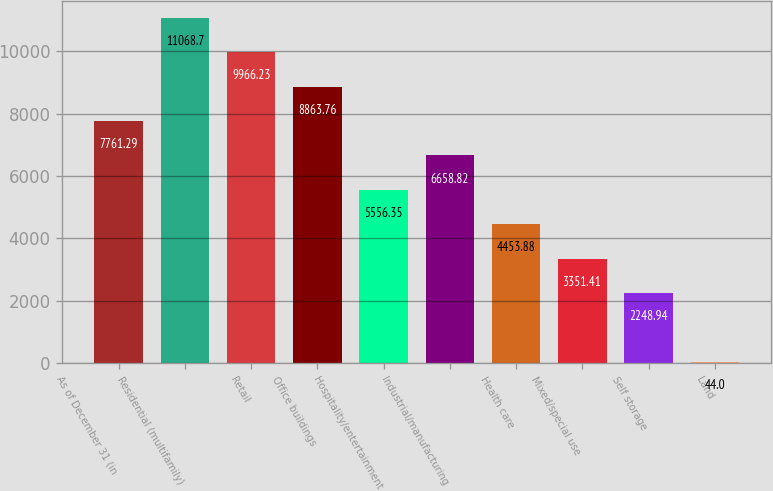Convert chart. <chart><loc_0><loc_0><loc_500><loc_500><bar_chart><fcel>As of December 31 (in<fcel>Residential (multifamily)<fcel>Retail<fcel>Office buildings<fcel>Hospitality/entertainment<fcel>Industrial/manufacturing<fcel>Health care<fcel>Mixed/special use<fcel>Self storage<fcel>Land<nl><fcel>7761.29<fcel>11068.7<fcel>9966.23<fcel>8863.76<fcel>5556.35<fcel>6658.82<fcel>4453.88<fcel>3351.41<fcel>2248.94<fcel>44<nl></chart> 